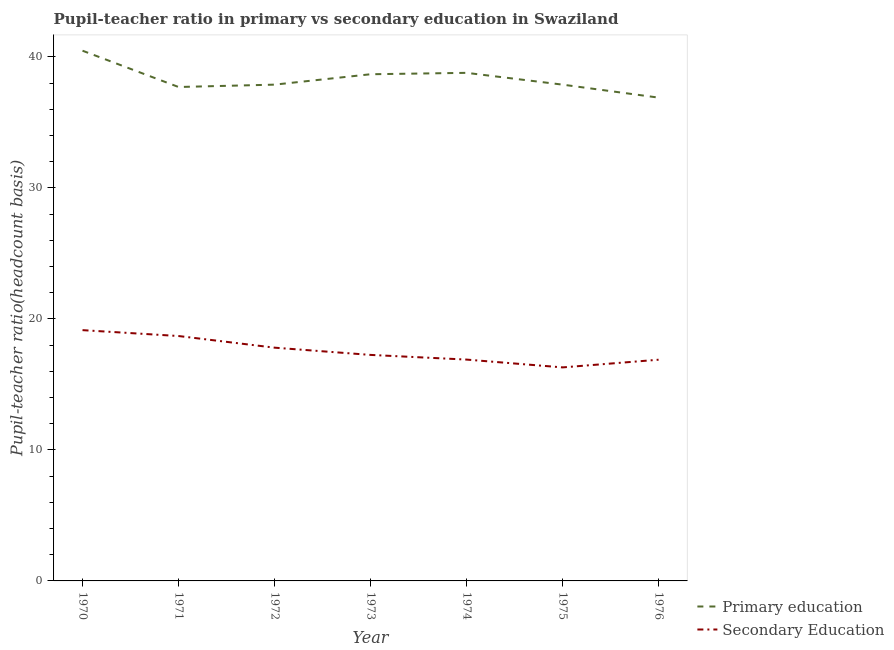Is the number of lines equal to the number of legend labels?
Ensure brevity in your answer.  Yes. What is the pupil-teacher ratio in primary education in 1976?
Keep it short and to the point. 36.9. Across all years, what is the maximum pupil-teacher ratio in primary education?
Your answer should be very brief. 40.48. Across all years, what is the minimum pupil-teacher ratio in primary education?
Provide a short and direct response. 36.9. In which year was the pupil-teacher ratio in primary education maximum?
Your answer should be very brief. 1970. In which year was the pupil-teacher ratio in primary education minimum?
Provide a succinct answer. 1976. What is the total pupil-teacher ratio in primary education in the graph?
Provide a short and direct response. 268.33. What is the difference between the pupil teacher ratio on secondary education in 1972 and that in 1973?
Provide a succinct answer. 0.55. What is the difference between the pupil teacher ratio on secondary education in 1971 and the pupil-teacher ratio in primary education in 1973?
Offer a terse response. -19.98. What is the average pupil-teacher ratio in primary education per year?
Ensure brevity in your answer.  38.33. In the year 1974, what is the difference between the pupil teacher ratio on secondary education and pupil-teacher ratio in primary education?
Your answer should be very brief. -21.89. In how many years, is the pupil-teacher ratio in primary education greater than 38?
Your answer should be very brief. 3. What is the ratio of the pupil teacher ratio on secondary education in 1975 to that in 1976?
Your answer should be very brief. 0.97. Is the difference between the pupil-teacher ratio in primary education in 1974 and 1976 greater than the difference between the pupil teacher ratio on secondary education in 1974 and 1976?
Ensure brevity in your answer.  Yes. What is the difference between the highest and the second highest pupil teacher ratio on secondary education?
Offer a terse response. 0.45. What is the difference between the highest and the lowest pupil-teacher ratio in primary education?
Your response must be concise. 3.58. In how many years, is the pupil-teacher ratio in primary education greater than the average pupil-teacher ratio in primary education taken over all years?
Make the answer very short. 3. Is the sum of the pupil-teacher ratio in primary education in 1971 and 1974 greater than the maximum pupil teacher ratio on secondary education across all years?
Offer a terse response. Yes. Is the pupil teacher ratio on secondary education strictly greater than the pupil-teacher ratio in primary education over the years?
Your answer should be very brief. No. Is the pupil teacher ratio on secondary education strictly less than the pupil-teacher ratio in primary education over the years?
Your answer should be compact. Yes. What is the difference between two consecutive major ticks on the Y-axis?
Keep it short and to the point. 10. How many legend labels are there?
Offer a very short reply. 2. What is the title of the graph?
Your answer should be compact. Pupil-teacher ratio in primary vs secondary education in Swaziland. What is the label or title of the X-axis?
Keep it short and to the point. Year. What is the label or title of the Y-axis?
Provide a short and direct response. Pupil-teacher ratio(headcount basis). What is the Pupil-teacher ratio(headcount basis) in Primary education in 1970?
Give a very brief answer. 40.48. What is the Pupil-teacher ratio(headcount basis) in Secondary Education in 1970?
Provide a short and direct response. 19.15. What is the Pupil-teacher ratio(headcount basis) of Primary education in 1971?
Provide a short and direct response. 37.71. What is the Pupil-teacher ratio(headcount basis) of Secondary Education in 1971?
Provide a succinct answer. 18.7. What is the Pupil-teacher ratio(headcount basis) of Primary education in 1972?
Your answer should be very brief. 37.89. What is the Pupil-teacher ratio(headcount basis) in Secondary Education in 1972?
Give a very brief answer. 17.81. What is the Pupil-teacher ratio(headcount basis) of Primary education in 1973?
Give a very brief answer. 38.68. What is the Pupil-teacher ratio(headcount basis) of Secondary Education in 1973?
Ensure brevity in your answer.  17.25. What is the Pupil-teacher ratio(headcount basis) of Primary education in 1974?
Offer a terse response. 38.79. What is the Pupil-teacher ratio(headcount basis) in Secondary Education in 1974?
Give a very brief answer. 16.9. What is the Pupil-teacher ratio(headcount basis) of Primary education in 1975?
Keep it short and to the point. 37.89. What is the Pupil-teacher ratio(headcount basis) in Secondary Education in 1975?
Provide a succinct answer. 16.3. What is the Pupil-teacher ratio(headcount basis) in Primary education in 1976?
Provide a succinct answer. 36.9. What is the Pupil-teacher ratio(headcount basis) of Secondary Education in 1976?
Provide a short and direct response. 16.89. Across all years, what is the maximum Pupil-teacher ratio(headcount basis) in Primary education?
Ensure brevity in your answer.  40.48. Across all years, what is the maximum Pupil-teacher ratio(headcount basis) of Secondary Education?
Provide a short and direct response. 19.15. Across all years, what is the minimum Pupil-teacher ratio(headcount basis) in Primary education?
Give a very brief answer. 36.9. Across all years, what is the minimum Pupil-teacher ratio(headcount basis) of Secondary Education?
Ensure brevity in your answer.  16.3. What is the total Pupil-teacher ratio(headcount basis) of Primary education in the graph?
Make the answer very short. 268.33. What is the total Pupil-teacher ratio(headcount basis) of Secondary Education in the graph?
Your answer should be very brief. 122.99. What is the difference between the Pupil-teacher ratio(headcount basis) in Primary education in 1970 and that in 1971?
Your answer should be very brief. 2.77. What is the difference between the Pupil-teacher ratio(headcount basis) in Secondary Education in 1970 and that in 1971?
Your answer should be very brief. 0.45. What is the difference between the Pupil-teacher ratio(headcount basis) of Primary education in 1970 and that in 1972?
Keep it short and to the point. 2.59. What is the difference between the Pupil-teacher ratio(headcount basis) in Secondary Education in 1970 and that in 1972?
Your answer should be very brief. 1.34. What is the difference between the Pupil-teacher ratio(headcount basis) of Primary education in 1970 and that in 1973?
Offer a terse response. 1.8. What is the difference between the Pupil-teacher ratio(headcount basis) in Secondary Education in 1970 and that in 1973?
Offer a very short reply. 1.89. What is the difference between the Pupil-teacher ratio(headcount basis) in Primary education in 1970 and that in 1974?
Provide a succinct answer. 1.69. What is the difference between the Pupil-teacher ratio(headcount basis) in Secondary Education in 1970 and that in 1974?
Provide a short and direct response. 2.25. What is the difference between the Pupil-teacher ratio(headcount basis) of Primary education in 1970 and that in 1975?
Your answer should be very brief. 2.59. What is the difference between the Pupil-teacher ratio(headcount basis) in Secondary Education in 1970 and that in 1975?
Your answer should be compact. 2.84. What is the difference between the Pupil-teacher ratio(headcount basis) in Primary education in 1970 and that in 1976?
Make the answer very short. 3.58. What is the difference between the Pupil-teacher ratio(headcount basis) of Secondary Education in 1970 and that in 1976?
Ensure brevity in your answer.  2.26. What is the difference between the Pupil-teacher ratio(headcount basis) of Primary education in 1971 and that in 1972?
Your response must be concise. -0.18. What is the difference between the Pupil-teacher ratio(headcount basis) of Secondary Education in 1971 and that in 1972?
Your answer should be very brief. 0.89. What is the difference between the Pupil-teacher ratio(headcount basis) in Primary education in 1971 and that in 1973?
Your answer should be very brief. -0.97. What is the difference between the Pupil-teacher ratio(headcount basis) in Secondary Education in 1971 and that in 1973?
Provide a succinct answer. 1.44. What is the difference between the Pupil-teacher ratio(headcount basis) in Primary education in 1971 and that in 1974?
Ensure brevity in your answer.  -1.08. What is the difference between the Pupil-teacher ratio(headcount basis) in Secondary Education in 1971 and that in 1974?
Ensure brevity in your answer.  1.8. What is the difference between the Pupil-teacher ratio(headcount basis) in Primary education in 1971 and that in 1975?
Your response must be concise. -0.18. What is the difference between the Pupil-teacher ratio(headcount basis) in Secondary Education in 1971 and that in 1975?
Ensure brevity in your answer.  2.4. What is the difference between the Pupil-teacher ratio(headcount basis) of Primary education in 1971 and that in 1976?
Provide a succinct answer. 0.81. What is the difference between the Pupil-teacher ratio(headcount basis) in Secondary Education in 1971 and that in 1976?
Make the answer very short. 1.81. What is the difference between the Pupil-teacher ratio(headcount basis) of Primary education in 1972 and that in 1973?
Provide a short and direct response. -0.79. What is the difference between the Pupil-teacher ratio(headcount basis) of Secondary Education in 1972 and that in 1973?
Your response must be concise. 0.55. What is the difference between the Pupil-teacher ratio(headcount basis) of Primary education in 1972 and that in 1974?
Your answer should be compact. -0.9. What is the difference between the Pupil-teacher ratio(headcount basis) of Secondary Education in 1972 and that in 1974?
Your answer should be very brief. 0.91. What is the difference between the Pupil-teacher ratio(headcount basis) of Primary education in 1972 and that in 1975?
Keep it short and to the point. -0. What is the difference between the Pupil-teacher ratio(headcount basis) of Secondary Education in 1972 and that in 1975?
Make the answer very short. 1.51. What is the difference between the Pupil-teacher ratio(headcount basis) of Secondary Education in 1972 and that in 1976?
Make the answer very short. 0.92. What is the difference between the Pupil-teacher ratio(headcount basis) of Primary education in 1973 and that in 1974?
Provide a succinct answer. -0.11. What is the difference between the Pupil-teacher ratio(headcount basis) in Secondary Education in 1973 and that in 1974?
Offer a very short reply. 0.36. What is the difference between the Pupil-teacher ratio(headcount basis) in Primary education in 1973 and that in 1975?
Give a very brief answer. 0.79. What is the difference between the Pupil-teacher ratio(headcount basis) in Secondary Education in 1973 and that in 1975?
Your response must be concise. 0.95. What is the difference between the Pupil-teacher ratio(headcount basis) in Primary education in 1973 and that in 1976?
Your answer should be compact. 1.78. What is the difference between the Pupil-teacher ratio(headcount basis) of Secondary Education in 1973 and that in 1976?
Make the answer very short. 0.37. What is the difference between the Pupil-teacher ratio(headcount basis) of Primary education in 1974 and that in 1975?
Make the answer very short. 0.9. What is the difference between the Pupil-teacher ratio(headcount basis) of Secondary Education in 1974 and that in 1975?
Your response must be concise. 0.6. What is the difference between the Pupil-teacher ratio(headcount basis) in Primary education in 1974 and that in 1976?
Your response must be concise. 1.89. What is the difference between the Pupil-teacher ratio(headcount basis) of Secondary Education in 1974 and that in 1976?
Provide a succinct answer. 0.01. What is the difference between the Pupil-teacher ratio(headcount basis) in Primary education in 1975 and that in 1976?
Give a very brief answer. 0.99. What is the difference between the Pupil-teacher ratio(headcount basis) of Secondary Education in 1975 and that in 1976?
Provide a succinct answer. -0.59. What is the difference between the Pupil-teacher ratio(headcount basis) of Primary education in 1970 and the Pupil-teacher ratio(headcount basis) of Secondary Education in 1971?
Your response must be concise. 21.78. What is the difference between the Pupil-teacher ratio(headcount basis) in Primary education in 1970 and the Pupil-teacher ratio(headcount basis) in Secondary Education in 1972?
Your answer should be very brief. 22.67. What is the difference between the Pupil-teacher ratio(headcount basis) in Primary education in 1970 and the Pupil-teacher ratio(headcount basis) in Secondary Education in 1973?
Provide a succinct answer. 23.22. What is the difference between the Pupil-teacher ratio(headcount basis) of Primary education in 1970 and the Pupil-teacher ratio(headcount basis) of Secondary Education in 1974?
Make the answer very short. 23.58. What is the difference between the Pupil-teacher ratio(headcount basis) in Primary education in 1970 and the Pupil-teacher ratio(headcount basis) in Secondary Education in 1975?
Make the answer very short. 24.18. What is the difference between the Pupil-teacher ratio(headcount basis) in Primary education in 1970 and the Pupil-teacher ratio(headcount basis) in Secondary Education in 1976?
Ensure brevity in your answer.  23.59. What is the difference between the Pupil-teacher ratio(headcount basis) in Primary education in 1971 and the Pupil-teacher ratio(headcount basis) in Secondary Education in 1972?
Make the answer very short. 19.9. What is the difference between the Pupil-teacher ratio(headcount basis) of Primary education in 1971 and the Pupil-teacher ratio(headcount basis) of Secondary Education in 1973?
Your answer should be very brief. 20.45. What is the difference between the Pupil-teacher ratio(headcount basis) of Primary education in 1971 and the Pupil-teacher ratio(headcount basis) of Secondary Education in 1974?
Keep it short and to the point. 20.81. What is the difference between the Pupil-teacher ratio(headcount basis) in Primary education in 1971 and the Pupil-teacher ratio(headcount basis) in Secondary Education in 1975?
Provide a short and direct response. 21.41. What is the difference between the Pupil-teacher ratio(headcount basis) of Primary education in 1971 and the Pupil-teacher ratio(headcount basis) of Secondary Education in 1976?
Offer a very short reply. 20.82. What is the difference between the Pupil-teacher ratio(headcount basis) of Primary education in 1972 and the Pupil-teacher ratio(headcount basis) of Secondary Education in 1973?
Give a very brief answer. 20.63. What is the difference between the Pupil-teacher ratio(headcount basis) in Primary education in 1972 and the Pupil-teacher ratio(headcount basis) in Secondary Education in 1974?
Offer a very short reply. 20.99. What is the difference between the Pupil-teacher ratio(headcount basis) of Primary education in 1972 and the Pupil-teacher ratio(headcount basis) of Secondary Education in 1975?
Offer a terse response. 21.59. What is the difference between the Pupil-teacher ratio(headcount basis) in Primary education in 1972 and the Pupil-teacher ratio(headcount basis) in Secondary Education in 1976?
Your answer should be compact. 21. What is the difference between the Pupil-teacher ratio(headcount basis) of Primary education in 1973 and the Pupil-teacher ratio(headcount basis) of Secondary Education in 1974?
Your response must be concise. 21.78. What is the difference between the Pupil-teacher ratio(headcount basis) in Primary education in 1973 and the Pupil-teacher ratio(headcount basis) in Secondary Education in 1975?
Provide a short and direct response. 22.38. What is the difference between the Pupil-teacher ratio(headcount basis) in Primary education in 1973 and the Pupil-teacher ratio(headcount basis) in Secondary Education in 1976?
Provide a succinct answer. 21.79. What is the difference between the Pupil-teacher ratio(headcount basis) in Primary education in 1974 and the Pupil-teacher ratio(headcount basis) in Secondary Education in 1975?
Give a very brief answer. 22.49. What is the difference between the Pupil-teacher ratio(headcount basis) of Primary education in 1974 and the Pupil-teacher ratio(headcount basis) of Secondary Education in 1976?
Provide a succinct answer. 21.9. What is the difference between the Pupil-teacher ratio(headcount basis) in Primary education in 1975 and the Pupil-teacher ratio(headcount basis) in Secondary Education in 1976?
Make the answer very short. 21. What is the average Pupil-teacher ratio(headcount basis) of Primary education per year?
Your response must be concise. 38.33. What is the average Pupil-teacher ratio(headcount basis) of Secondary Education per year?
Provide a short and direct response. 17.57. In the year 1970, what is the difference between the Pupil-teacher ratio(headcount basis) of Primary education and Pupil-teacher ratio(headcount basis) of Secondary Education?
Offer a very short reply. 21.33. In the year 1971, what is the difference between the Pupil-teacher ratio(headcount basis) in Primary education and Pupil-teacher ratio(headcount basis) in Secondary Education?
Your response must be concise. 19.01. In the year 1972, what is the difference between the Pupil-teacher ratio(headcount basis) in Primary education and Pupil-teacher ratio(headcount basis) in Secondary Education?
Your response must be concise. 20.08. In the year 1973, what is the difference between the Pupil-teacher ratio(headcount basis) in Primary education and Pupil-teacher ratio(headcount basis) in Secondary Education?
Offer a terse response. 21.43. In the year 1974, what is the difference between the Pupil-teacher ratio(headcount basis) in Primary education and Pupil-teacher ratio(headcount basis) in Secondary Education?
Make the answer very short. 21.89. In the year 1975, what is the difference between the Pupil-teacher ratio(headcount basis) in Primary education and Pupil-teacher ratio(headcount basis) in Secondary Education?
Keep it short and to the point. 21.59. In the year 1976, what is the difference between the Pupil-teacher ratio(headcount basis) in Primary education and Pupil-teacher ratio(headcount basis) in Secondary Education?
Your answer should be very brief. 20.01. What is the ratio of the Pupil-teacher ratio(headcount basis) of Primary education in 1970 to that in 1971?
Your response must be concise. 1.07. What is the ratio of the Pupil-teacher ratio(headcount basis) of Secondary Education in 1970 to that in 1971?
Your response must be concise. 1.02. What is the ratio of the Pupil-teacher ratio(headcount basis) in Primary education in 1970 to that in 1972?
Make the answer very short. 1.07. What is the ratio of the Pupil-teacher ratio(headcount basis) in Secondary Education in 1970 to that in 1972?
Your answer should be compact. 1.08. What is the ratio of the Pupil-teacher ratio(headcount basis) in Primary education in 1970 to that in 1973?
Give a very brief answer. 1.05. What is the ratio of the Pupil-teacher ratio(headcount basis) of Secondary Education in 1970 to that in 1973?
Offer a very short reply. 1.11. What is the ratio of the Pupil-teacher ratio(headcount basis) of Primary education in 1970 to that in 1974?
Offer a very short reply. 1.04. What is the ratio of the Pupil-teacher ratio(headcount basis) of Secondary Education in 1970 to that in 1974?
Your response must be concise. 1.13. What is the ratio of the Pupil-teacher ratio(headcount basis) of Primary education in 1970 to that in 1975?
Make the answer very short. 1.07. What is the ratio of the Pupil-teacher ratio(headcount basis) of Secondary Education in 1970 to that in 1975?
Ensure brevity in your answer.  1.17. What is the ratio of the Pupil-teacher ratio(headcount basis) in Primary education in 1970 to that in 1976?
Provide a succinct answer. 1.1. What is the ratio of the Pupil-teacher ratio(headcount basis) in Secondary Education in 1970 to that in 1976?
Your answer should be very brief. 1.13. What is the ratio of the Pupil-teacher ratio(headcount basis) in Secondary Education in 1971 to that in 1972?
Provide a succinct answer. 1.05. What is the ratio of the Pupil-teacher ratio(headcount basis) in Primary education in 1971 to that in 1973?
Offer a terse response. 0.97. What is the ratio of the Pupil-teacher ratio(headcount basis) in Secondary Education in 1971 to that in 1973?
Ensure brevity in your answer.  1.08. What is the ratio of the Pupil-teacher ratio(headcount basis) in Primary education in 1971 to that in 1974?
Offer a very short reply. 0.97. What is the ratio of the Pupil-teacher ratio(headcount basis) of Secondary Education in 1971 to that in 1974?
Ensure brevity in your answer.  1.11. What is the ratio of the Pupil-teacher ratio(headcount basis) in Primary education in 1971 to that in 1975?
Provide a short and direct response. 1. What is the ratio of the Pupil-teacher ratio(headcount basis) of Secondary Education in 1971 to that in 1975?
Your response must be concise. 1.15. What is the ratio of the Pupil-teacher ratio(headcount basis) of Secondary Education in 1971 to that in 1976?
Give a very brief answer. 1.11. What is the ratio of the Pupil-teacher ratio(headcount basis) in Primary education in 1972 to that in 1973?
Provide a succinct answer. 0.98. What is the ratio of the Pupil-teacher ratio(headcount basis) of Secondary Education in 1972 to that in 1973?
Your response must be concise. 1.03. What is the ratio of the Pupil-teacher ratio(headcount basis) in Primary education in 1972 to that in 1974?
Your answer should be very brief. 0.98. What is the ratio of the Pupil-teacher ratio(headcount basis) in Secondary Education in 1972 to that in 1974?
Provide a short and direct response. 1.05. What is the ratio of the Pupil-teacher ratio(headcount basis) in Primary education in 1972 to that in 1975?
Your response must be concise. 1. What is the ratio of the Pupil-teacher ratio(headcount basis) of Secondary Education in 1972 to that in 1975?
Provide a short and direct response. 1.09. What is the ratio of the Pupil-teacher ratio(headcount basis) in Primary education in 1972 to that in 1976?
Your answer should be very brief. 1.03. What is the ratio of the Pupil-teacher ratio(headcount basis) in Secondary Education in 1972 to that in 1976?
Provide a succinct answer. 1.05. What is the ratio of the Pupil-teacher ratio(headcount basis) in Primary education in 1973 to that in 1974?
Your answer should be compact. 1. What is the ratio of the Pupil-teacher ratio(headcount basis) of Secondary Education in 1973 to that in 1974?
Offer a very short reply. 1.02. What is the ratio of the Pupil-teacher ratio(headcount basis) in Primary education in 1973 to that in 1975?
Provide a short and direct response. 1.02. What is the ratio of the Pupil-teacher ratio(headcount basis) in Secondary Education in 1973 to that in 1975?
Provide a short and direct response. 1.06. What is the ratio of the Pupil-teacher ratio(headcount basis) in Primary education in 1973 to that in 1976?
Your response must be concise. 1.05. What is the ratio of the Pupil-teacher ratio(headcount basis) of Secondary Education in 1973 to that in 1976?
Provide a succinct answer. 1.02. What is the ratio of the Pupil-teacher ratio(headcount basis) in Primary education in 1974 to that in 1975?
Provide a short and direct response. 1.02. What is the ratio of the Pupil-teacher ratio(headcount basis) in Secondary Education in 1974 to that in 1975?
Offer a terse response. 1.04. What is the ratio of the Pupil-teacher ratio(headcount basis) of Primary education in 1974 to that in 1976?
Keep it short and to the point. 1.05. What is the ratio of the Pupil-teacher ratio(headcount basis) of Secondary Education in 1974 to that in 1976?
Provide a short and direct response. 1. What is the ratio of the Pupil-teacher ratio(headcount basis) in Primary education in 1975 to that in 1976?
Keep it short and to the point. 1.03. What is the ratio of the Pupil-teacher ratio(headcount basis) in Secondary Education in 1975 to that in 1976?
Keep it short and to the point. 0.97. What is the difference between the highest and the second highest Pupil-teacher ratio(headcount basis) in Primary education?
Make the answer very short. 1.69. What is the difference between the highest and the second highest Pupil-teacher ratio(headcount basis) in Secondary Education?
Your answer should be compact. 0.45. What is the difference between the highest and the lowest Pupil-teacher ratio(headcount basis) of Primary education?
Ensure brevity in your answer.  3.58. What is the difference between the highest and the lowest Pupil-teacher ratio(headcount basis) of Secondary Education?
Keep it short and to the point. 2.84. 